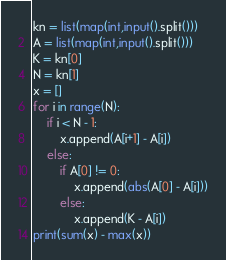Convert code to text. <code><loc_0><loc_0><loc_500><loc_500><_Python_>kn = list(map(int,input().split()))
A = list(map(int,input().split()))
K = kn[0]
N = kn[1]
x = []
for i in range(N):
    if i < N - 1:
        x.append(A[i+1] - A[i])
    else:
        if A[0] != 0:
            x.append(abs(A[0] - A[i]))
        else:
            x.append(K - A[i])
print(sum(x) - max(x))</code> 